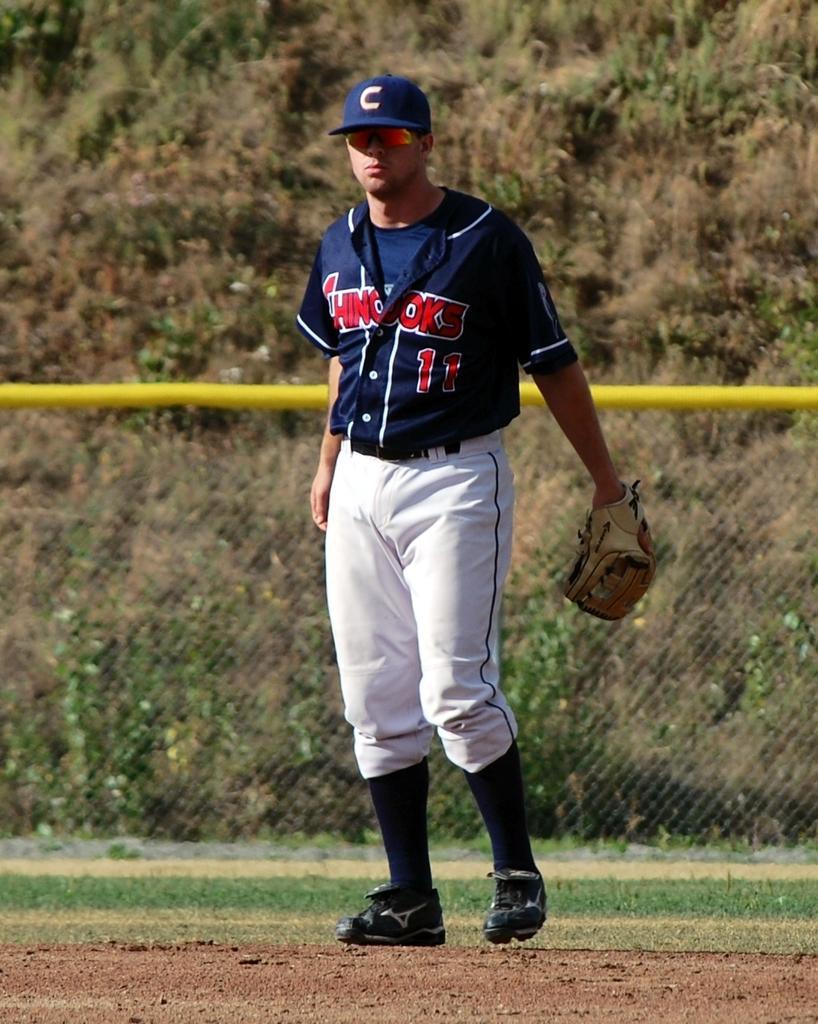Describe this image in one or two sentences. In this picture we can see a person standing on the ground, he is wearing a glove and in the background we can see a fence, trees. 